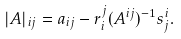Convert formula to latex. <formula><loc_0><loc_0><loc_500><loc_500>| A | _ { i j } & = a _ { i j } - r _ { i } ^ { j } ( A ^ { i j } ) ^ { - 1 } s _ { j } ^ { i } .</formula> 